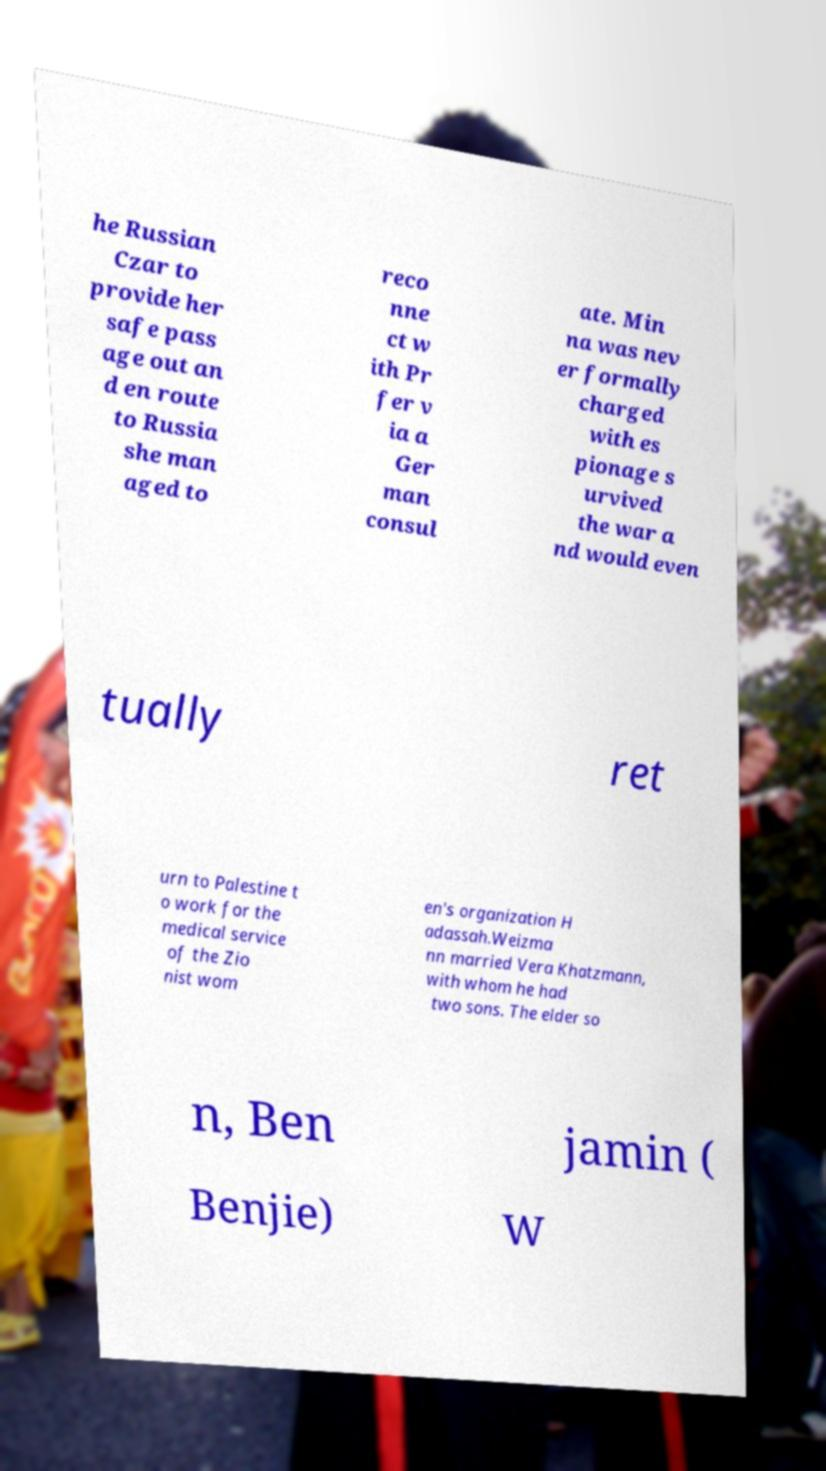Please identify and transcribe the text found in this image. he Russian Czar to provide her safe pass age out an d en route to Russia she man aged to reco nne ct w ith Pr fer v ia a Ger man consul ate. Min na was nev er formally charged with es pionage s urvived the war a nd would even tually ret urn to Palestine t o work for the medical service of the Zio nist wom en's organization H adassah.Weizma nn married Vera Khatzmann, with whom he had two sons. The elder so n, Ben jamin ( Benjie) W 